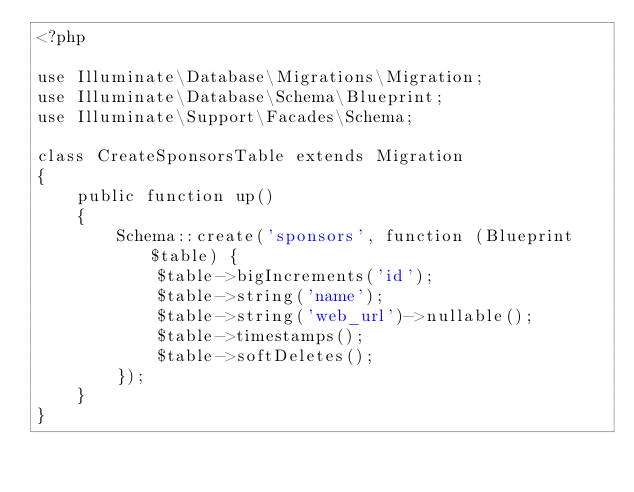<code> <loc_0><loc_0><loc_500><loc_500><_PHP_><?php

use Illuminate\Database\Migrations\Migration;
use Illuminate\Database\Schema\Blueprint;
use Illuminate\Support\Facades\Schema;

class CreateSponsorsTable extends Migration
{
    public function up()
    {
        Schema::create('sponsors', function (Blueprint $table) {
            $table->bigIncrements('id');
            $table->string('name');
            $table->string('web_url')->nullable();
            $table->timestamps();
            $table->softDeletes();
        });
    }
}
</code> 